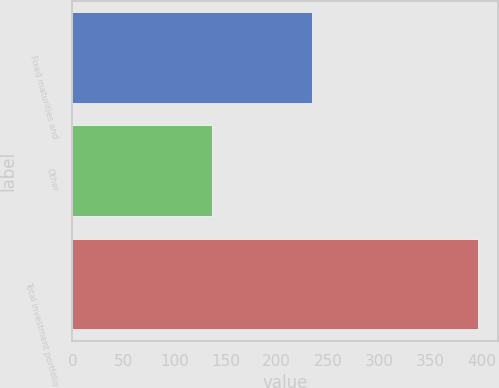Convert chart to OTSL. <chart><loc_0><loc_0><loc_500><loc_500><bar_chart><fcel>Fixed maturities and<fcel>Other<fcel>Total investment portfolio<nl><fcel>234<fcel>137<fcel>397<nl></chart> 